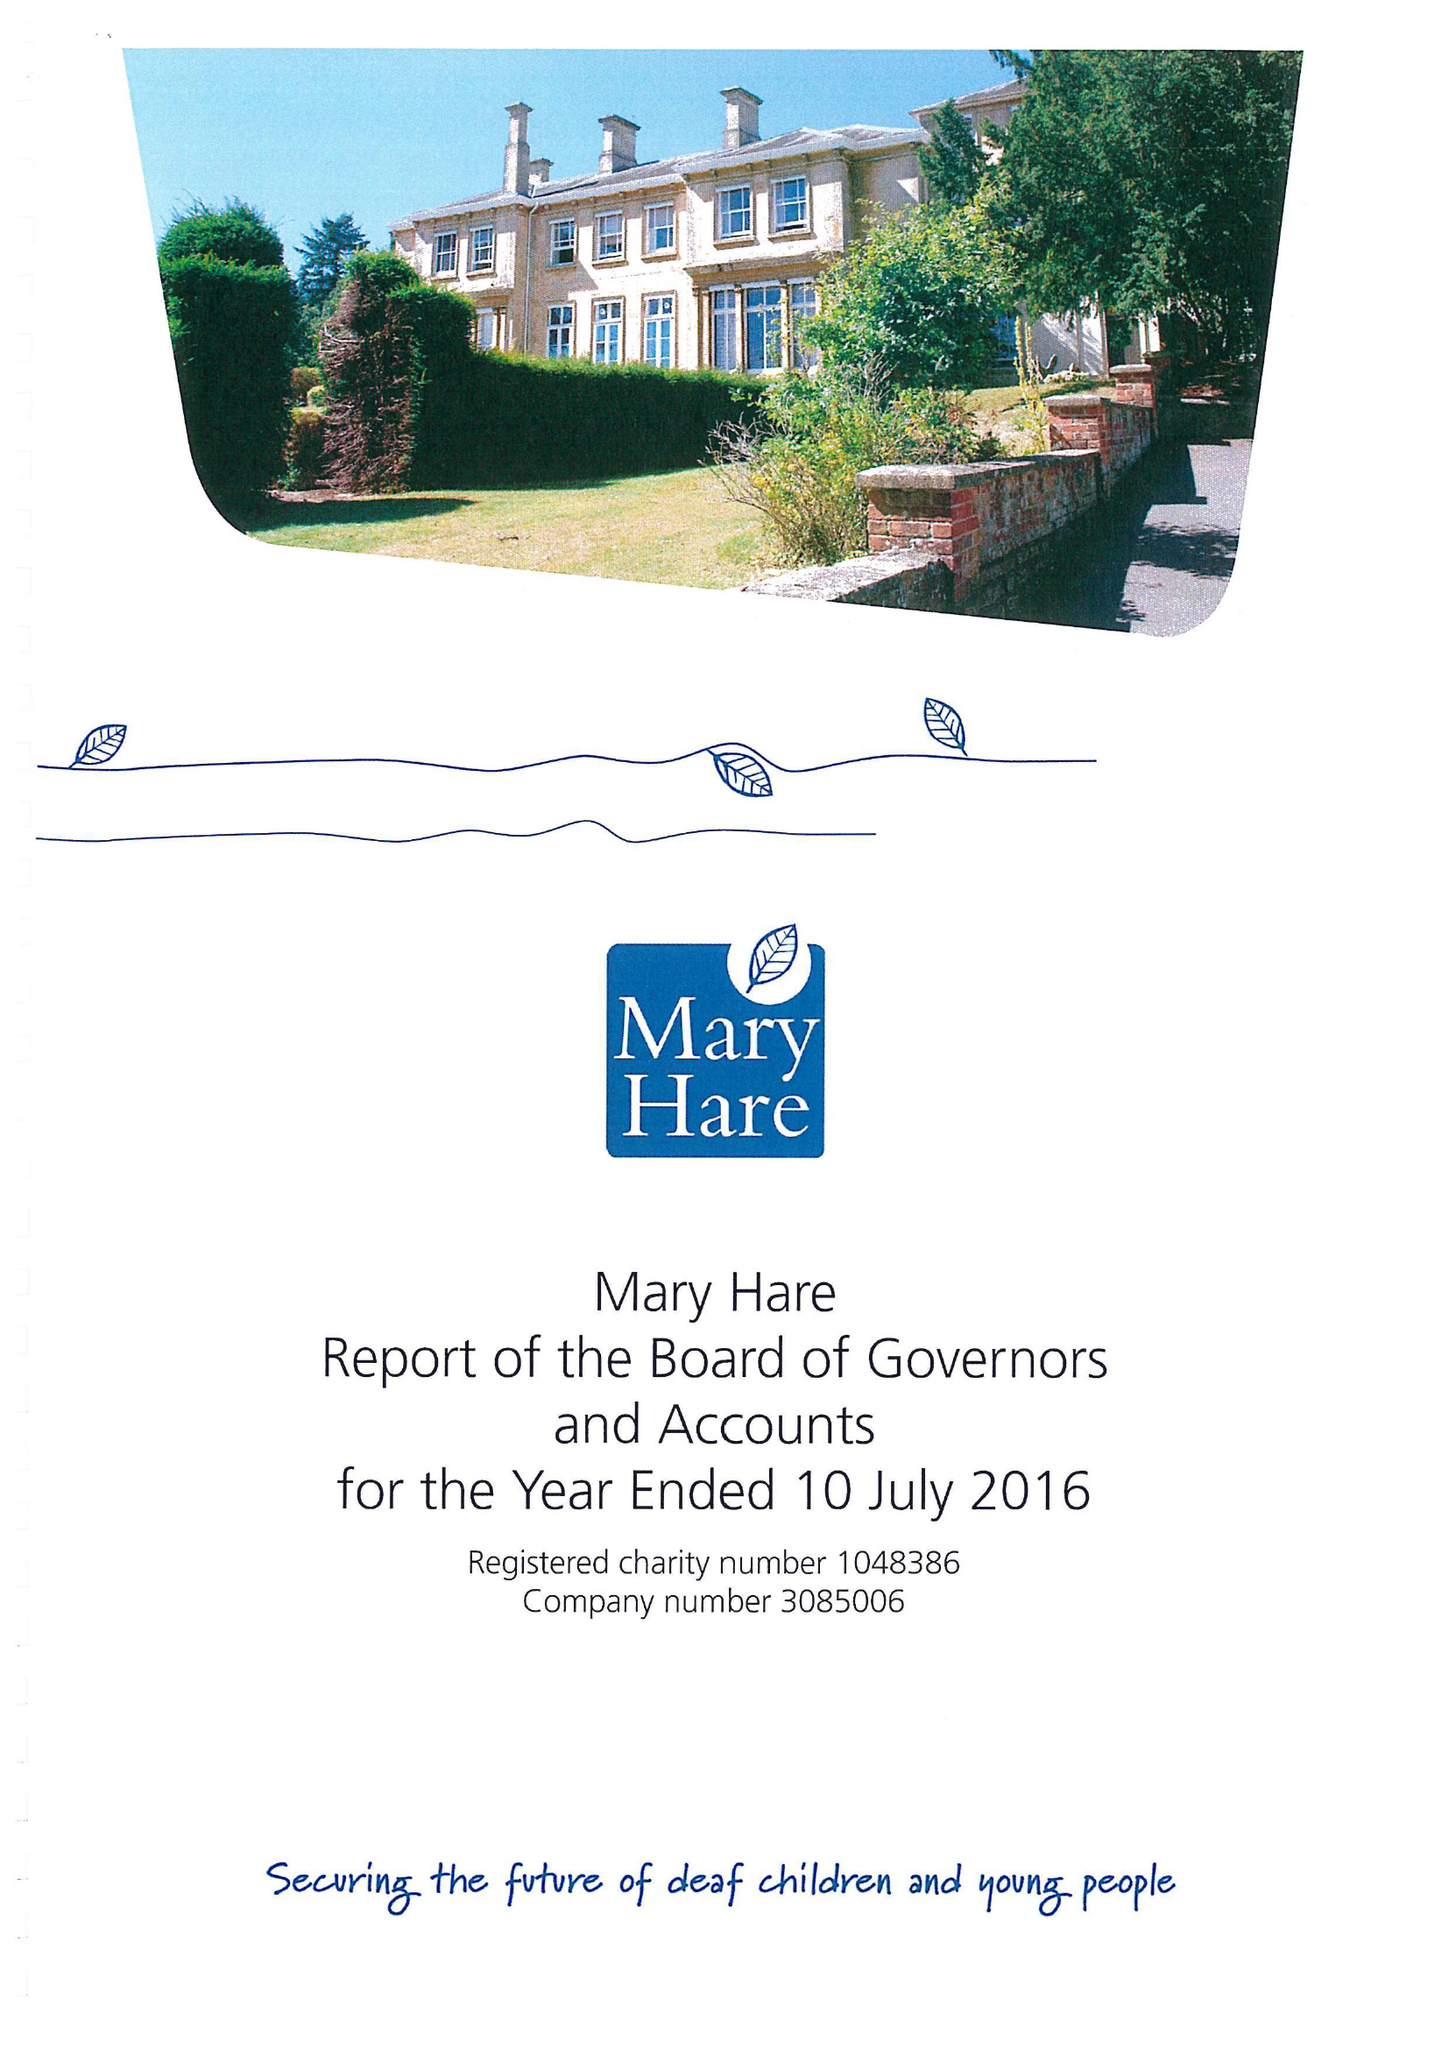What is the value for the address__post_town?
Answer the question using a single word or phrase. NEWBURY 